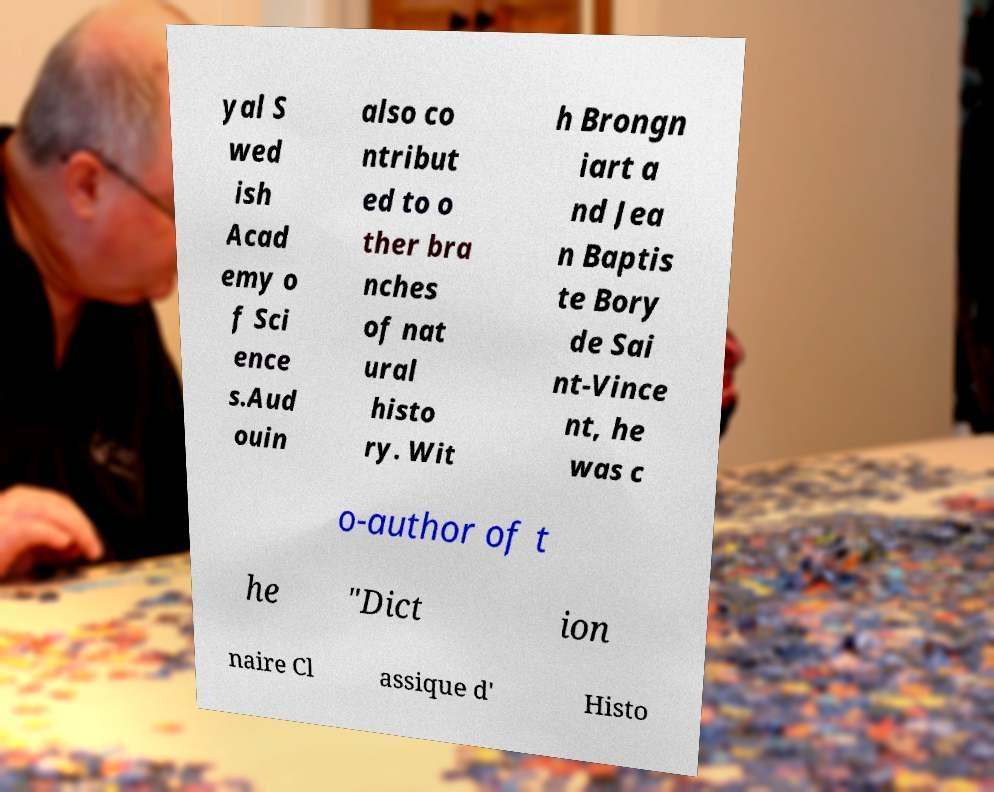There's text embedded in this image that I need extracted. Can you transcribe it verbatim? yal S wed ish Acad emy o f Sci ence s.Aud ouin also co ntribut ed to o ther bra nches of nat ural histo ry. Wit h Brongn iart a nd Jea n Baptis te Bory de Sai nt-Vince nt, he was c o-author of t he "Dict ion naire Cl assique d' Histo 